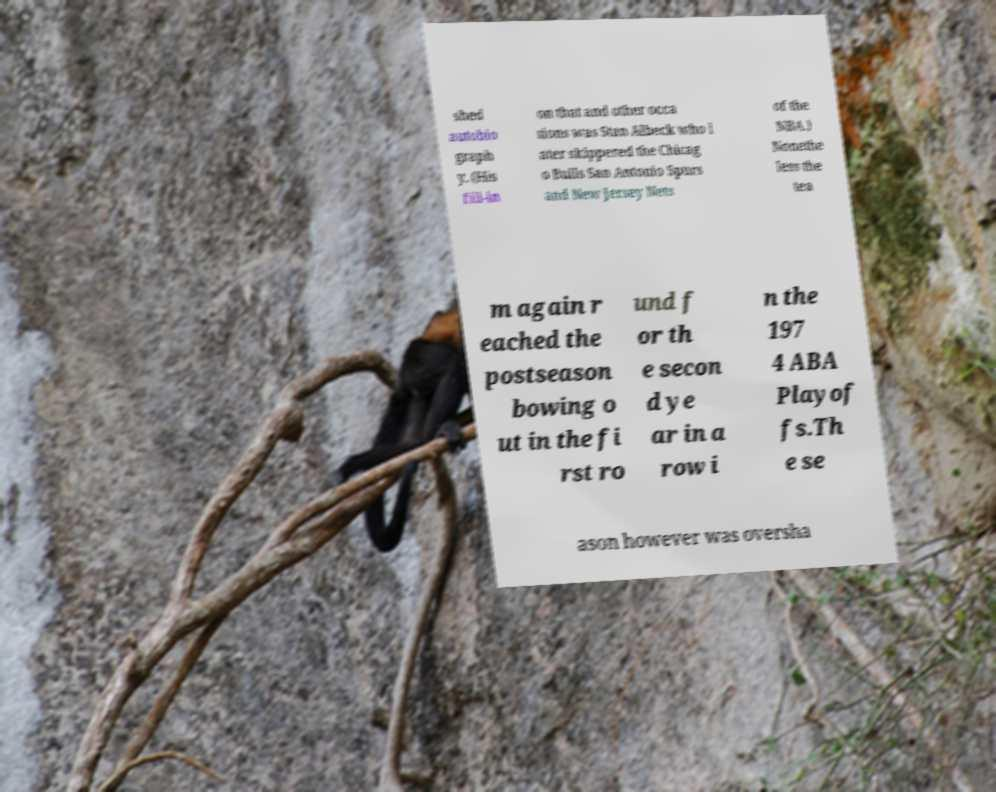What messages or text are displayed in this image? I need them in a readable, typed format. shed autobio graph y. (His fill-in on that and other occa sions was Stan Albeck who l ater skippered the Chicag o Bulls San Antonio Spurs and New Jersey Nets of the NBA.) Nonethe less the tea m again r eached the postseason bowing o ut in the fi rst ro und f or th e secon d ye ar in a row i n the 197 4 ABA Playof fs.Th e se ason however was oversha 